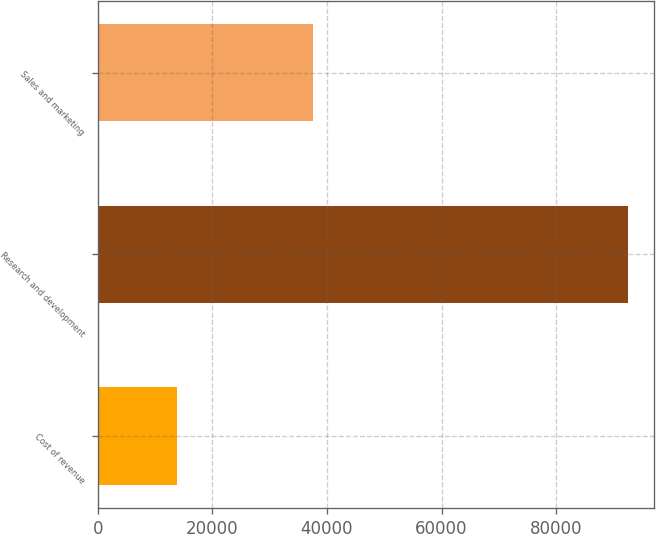Convert chart to OTSL. <chart><loc_0><loc_0><loc_500><loc_500><bar_chart><fcel>Cost of revenue<fcel>Research and development<fcel>Sales and marketing<nl><fcel>13869<fcel>92493<fcel>37547<nl></chart> 